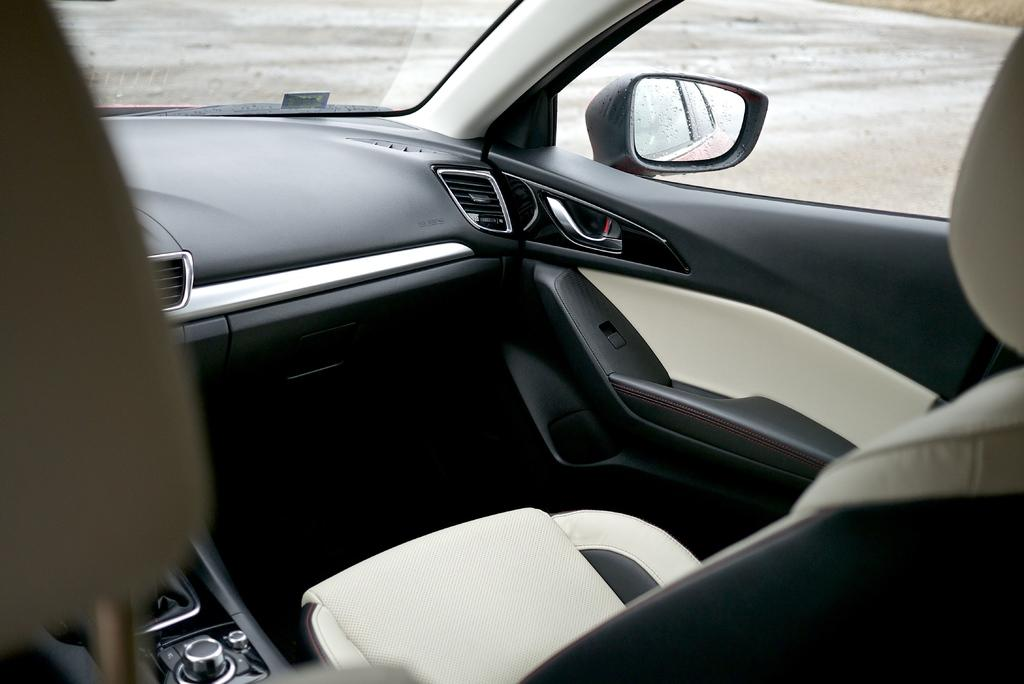What type of space is depicted in the image? The image shows an interior view of a vehicle. What can be found inside the vehicle? There are seats visible in the image. What feature is present for the driver to see behind them? There is a mirror in the image. What can be used to control various functions in the vehicle? There are buttons present in the image. Where is the pan located in the image? There is no pan present in the image. Can you see the person's self in the mirror in the image? The image does not show a person, so it is impossible to determine if their self is visible in the mirror. 